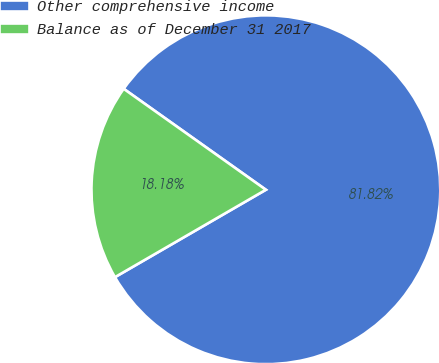Convert chart. <chart><loc_0><loc_0><loc_500><loc_500><pie_chart><fcel>Other comprehensive income<fcel>Balance as of December 31 2017<nl><fcel>81.82%<fcel>18.18%<nl></chart> 